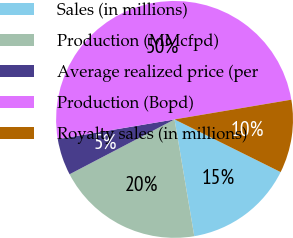Convert chart. <chart><loc_0><loc_0><loc_500><loc_500><pie_chart><fcel>Sales (in millions)<fcel>Production (MMcfpd)<fcel>Average realized price (per<fcel>Production (Bopd)<fcel>Royalty sales (in millions)<nl><fcel>15.0%<fcel>20.0%<fcel>5.0%<fcel>50.0%<fcel>10.0%<nl></chart> 